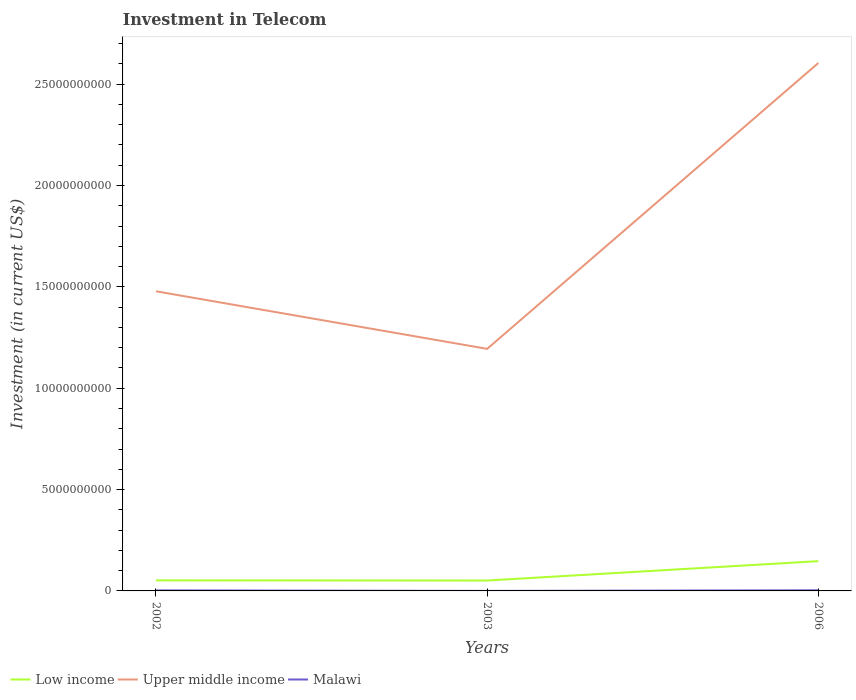Across all years, what is the maximum amount invested in telecom in Low income?
Give a very brief answer. 5.13e+08. In which year was the amount invested in telecom in Upper middle income maximum?
Your response must be concise. 2003. What is the total amount invested in telecom in Low income in the graph?
Ensure brevity in your answer.  7.62e+06. What is the difference between the highest and the second highest amount invested in telecom in Upper middle income?
Give a very brief answer. 1.41e+1. What is the difference between the highest and the lowest amount invested in telecom in Low income?
Your answer should be compact. 1. Is the amount invested in telecom in Upper middle income strictly greater than the amount invested in telecom in Malawi over the years?
Provide a short and direct response. No. What is the difference between two consecutive major ticks on the Y-axis?
Your answer should be compact. 5.00e+09. Are the values on the major ticks of Y-axis written in scientific E-notation?
Ensure brevity in your answer.  No. Does the graph contain any zero values?
Make the answer very short. No. What is the title of the graph?
Provide a succinct answer. Investment in Telecom. Does "Peru" appear as one of the legend labels in the graph?
Your response must be concise. No. What is the label or title of the Y-axis?
Ensure brevity in your answer.  Investment (in current US$). What is the Investment (in current US$) of Low income in 2002?
Provide a short and direct response. 5.20e+08. What is the Investment (in current US$) of Upper middle income in 2002?
Keep it short and to the point. 1.48e+1. What is the Investment (in current US$) of Malawi in 2002?
Make the answer very short. 2.60e+07. What is the Investment (in current US$) of Low income in 2003?
Give a very brief answer. 5.13e+08. What is the Investment (in current US$) of Upper middle income in 2003?
Your answer should be compact. 1.19e+1. What is the Investment (in current US$) in Low income in 2006?
Offer a terse response. 1.47e+09. What is the Investment (in current US$) of Upper middle income in 2006?
Provide a short and direct response. 2.60e+1. What is the Investment (in current US$) of Malawi in 2006?
Give a very brief answer. 3.05e+07. Across all years, what is the maximum Investment (in current US$) in Low income?
Give a very brief answer. 1.47e+09. Across all years, what is the maximum Investment (in current US$) in Upper middle income?
Provide a short and direct response. 2.60e+1. Across all years, what is the maximum Investment (in current US$) of Malawi?
Make the answer very short. 3.05e+07. Across all years, what is the minimum Investment (in current US$) of Low income?
Provide a succinct answer. 5.13e+08. Across all years, what is the minimum Investment (in current US$) in Upper middle income?
Your answer should be compact. 1.19e+1. Across all years, what is the minimum Investment (in current US$) of Malawi?
Provide a short and direct response. 9.00e+05. What is the total Investment (in current US$) in Low income in the graph?
Offer a very short reply. 2.50e+09. What is the total Investment (in current US$) of Upper middle income in the graph?
Provide a short and direct response. 5.28e+1. What is the total Investment (in current US$) in Malawi in the graph?
Ensure brevity in your answer.  5.74e+07. What is the difference between the Investment (in current US$) in Low income in 2002 and that in 2003?
Ensure brevity in your answer.  7.62e+06. What is the difference between the Investment (in current US$) of Upper middle income in 2002 and that in 2003?
Give a very brief answer. 2.84e+09. What is the difference between the Investment (in current US$) in Malawi in 2002 and that in 2003?
Give a very brief answer. 2.51e+07. What is the difference between the Investment (in current US$) of Low income in 2002 and that in 2006?
Your answer should be very brief. -9.48e+08. What is the difference between the Investment (in current US$) of Upper middle income in 2002 and that in 2006?
Provide a succinct answer. -1.13e+1. What is the difference between the Investment (in current US$) in Malawi in 2002 and that in 2006?
Your answer should be very brief. -4.50e+06. What is the difference between the Investment (in current US$) in Low income in 2003 and that in 2006?
Provide a short and direct response. -9.55e+08. What is the difference between the Investment (in current US$) in Upper middle income in 2003 and that in 2006?
Offer a terse response. -1.41e+1. What is the difference between the Investment (in current US$) of Malawi in 2003 and that in 2006?
Provide a short and direct response. -2.96e+07. What is the difference between the Investment (in current US$) in Low income in 2002 and the Investment (in current US$) in Upper middle income in 2003?
Provide a succinct answer. -1.14e+1. What is the difference between the Investment (in current US$) in Low income in 2002 and the Investment (in current US$) in Malawi in 2003?
Provide a short and direct response. 5.20e+08. What is the difference between the Investment (in current US$) of Upper middle income in 2002 and the Investment (in current US$) of Malawi in 2003?
Provide a succinct answer. 1.48e+1. What is the difference between the Investment (in current US$) in Low income in 2002 and the Investment (in current US$) in Upper middle income in 2006?
Make the answer very short. -2.55e+1. What is the difference between the Investment (in current US$) in Low income in 2002 and the Investment (in current US$) in Malawi in 2006?
Provide a succinct answer. 4.90e+08. What is the difference between the Investment (in current US$) in Upper middle income in 2002 and the Investment (in current US$) in Malawi in 2006?
Ensure brevity in your answer.  1.48e+1. What is the difference between the Investment (in current US$) in Low income in 2003 and the Investment (in current US$) in Upper middle income in 2006?
Ensure brevity in your answer.  -2.55e+1. What is the difference between the Investment (in current US$) of Low income in 2003 and the Investment (in current US$) of Malawi in 2006?
Make the answer very short. 4.82e+08. What is the difference between the Investment (in current US$) in Upper middle income in 2003 and the Investment (in current US$) in Malawi in 2006?
Your response must be concise. 1.19e+1. What is the average Investment (in current US$) of Low income per year?
Ensure brevity in your answer.  8.34e+08. What is the average Investment (in current US$) of Upper middle income per year?
Your answer should be compact. 1.76e+1. What is the average Investment (in current US$) of Malawi per year?
Offer a terse response. 1.91e+07. In the year 2002, what is the difference between the Investment (in current US$) in Low income and Investment (in current US$) in Upper middle income?
Give a very brief answer. -1.43e+1. In the year 2002, what is the difference between the Investment (in current US$) of Low income and Investment (in current US$) of Malawi?
Ensure brevity in your answer.  4.94e+08. In the year 2002, what is the difference between the Investment (in current US$) of Upper middle income and Investment (in current US$) of Malawi?
Provide a succinct answer. 1.48e+1. In the year 2003, what is the difference between the Investment (in current US$) in Low income and Investment (in current US$) in Upper middle income?
Keep it short and to the point. -1.14e+1. In the year 2003, what is the difference between the Investment (in current US$) in Low income and Investment (in current US$) in Malawi?
Your answer should be compact. 5.12e+08. In the year 2003, what is the difference between the Investment (in current US$) in Upper middle income and Investment (in current US$) in Malawi?
Give a very brief answer. 1.19e+1. In the year 2006, what is the difference between the Investment (in current US$) of Low income and Investment (in current US$) of Upper middle income?
Your answer should be compact. -2.46e+1. In the year 2006, what is the difference between the Investment (in current US$) of Low income and Investment (in current US$) of Malawi?
Your response must be concise. 1.44e+09. In the year 2006, what is the difference between the Investment (in current US$) in Upper middle income and Investment (in current US$) in Malawi?
Provide a short and direct response. 2.60e+1. What is the ratio of the Investment (in current US$) of Low income in 2002 to that in 2003?
Your response must be concise. 1.01. What is the ratio of the Investment (in current US$) in Upper middle income in 2002 to that in 2003?
Ensure brevity in your answer.  1.24. What is the ratio of the Investment (in current US$) of Malawi in 2002 to that in 2003?
Offer a very short reply. 28.89. What is the ratio of the Investment (in current US$) of Low income in 2002 to that in 2006?
Your answer should be very brief. 0.35. What is the ratio of the Investment (in current US$) in Upper middle income in 2002 to that in 2006?
Ensure brevity in your answer.  0.57. What is the ratio of the Investment (in current US$) of Malawi in 2002 to that in 2006?
Your answer should be compact. 0.85. What is the ratio of the Investment (in current US$) in Low income in 2003 to that in 2006?
Offer a very short reply. 0.35. What is the ratio of the Investment (in current US$) in Upper middle income in 2003 to that in 2006?
Your answer should be very brief. 0.46. What is the ratio of the Investment (in current US$) in Malawi in 2003 to that in 2006?
Ensure brevity in your answer.  0.03. What is the difference between the highest and the second highest Investment (in current US$) in Low income?
Your answer should be very brief. 9.48e+08. What is the difference between the highest and the second highest Investment (in current US$) in Upper middle income?
Ensure brevity in your answer.  1.13e+1. What is the difference between the highest and the second highest Investment (in current US$) in Malawi?
Your response must be concise. 4.50e+06. What is the difference between the highest and the lowest Investment (in current US$) in Low income?
Your answer should be very brief. 9.55e+08. What is the difference between the highest and the lowest Investment (in current US$) in Upper middle income?
Ensure brevity in your answer.  1.41e+1. What is the difference between the highest and the lowest Investment (in current US$) of Malawi?
Keep it short and to the point. 2.96e+07. 